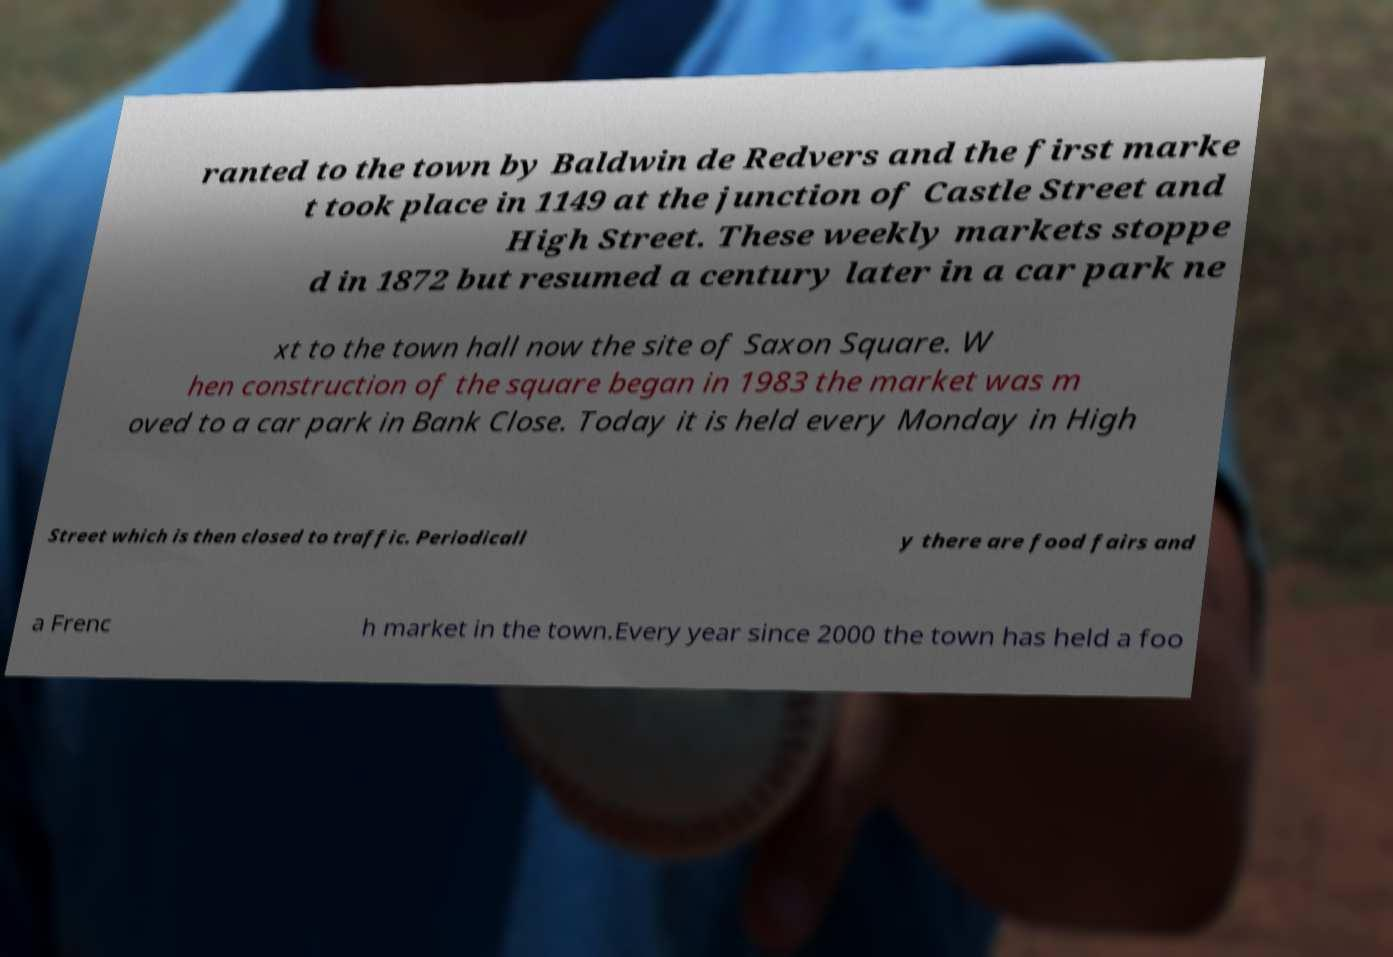Can you read and provide the text displayed in the image?This photo seems to have some interesting text. Can you extract and type it out for me? ranted to the town by Baldwin de Redvers and the first marke t took place in 1149 at the junction of Castle Street and High Street. These weekly markets stoppe d in 1872 but resumed a century later in a car park ne xt to the town hall now the site of Saxon Square. W hen construction of the square began in 1983 the market was m oved to a car park in Bank Close. Today it is held every Monday in High Street which is then closed to traffic. Periodicall y there are food fairs and a Frenc h market in the town.Every year since 2000 the town has held a foo 